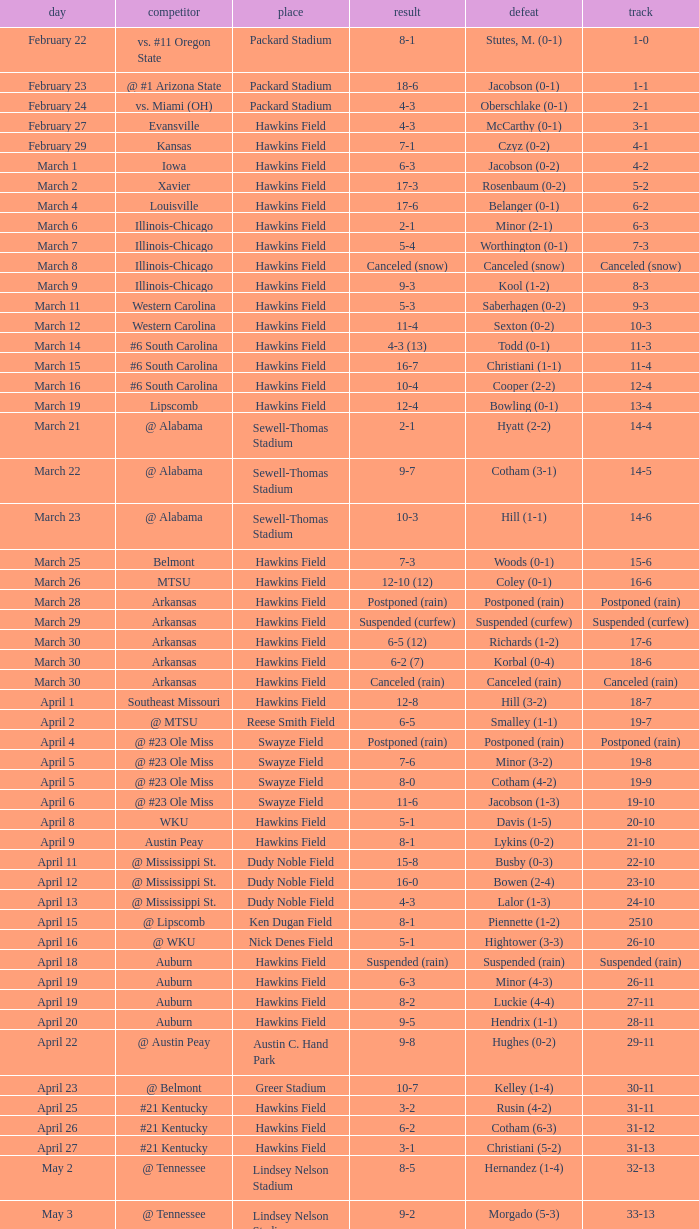What was the location of the game when the record was 2-1? Packard Stadium. 